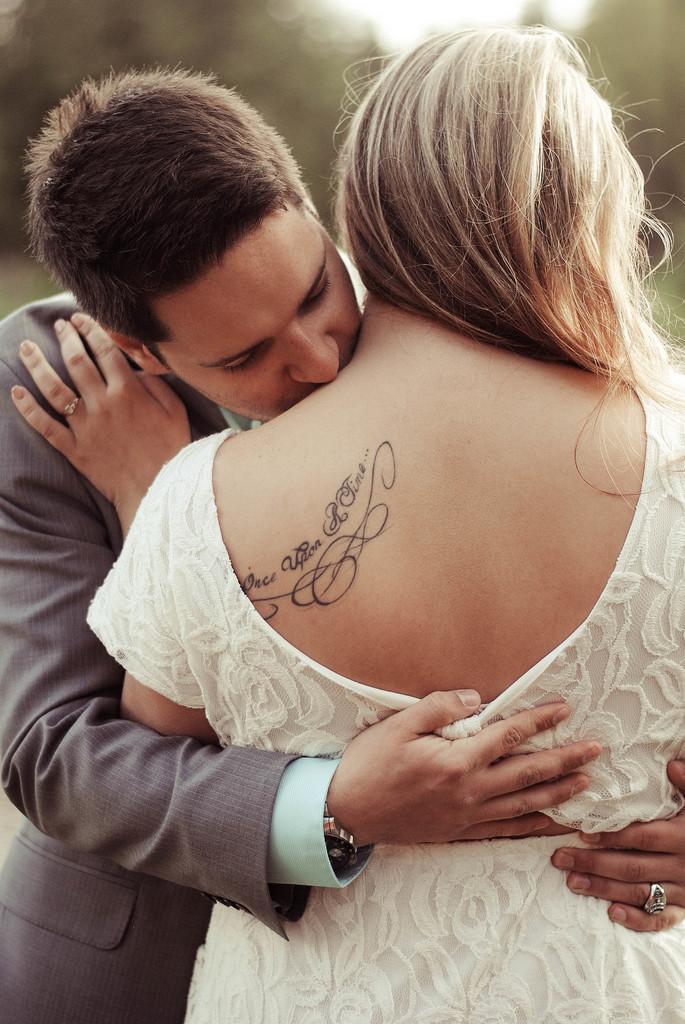Can you describe this image briefly? In this image we can see a couple hugging each other, the lady is wearing a white dress, and she has a tattoo, and the background is blurred. 